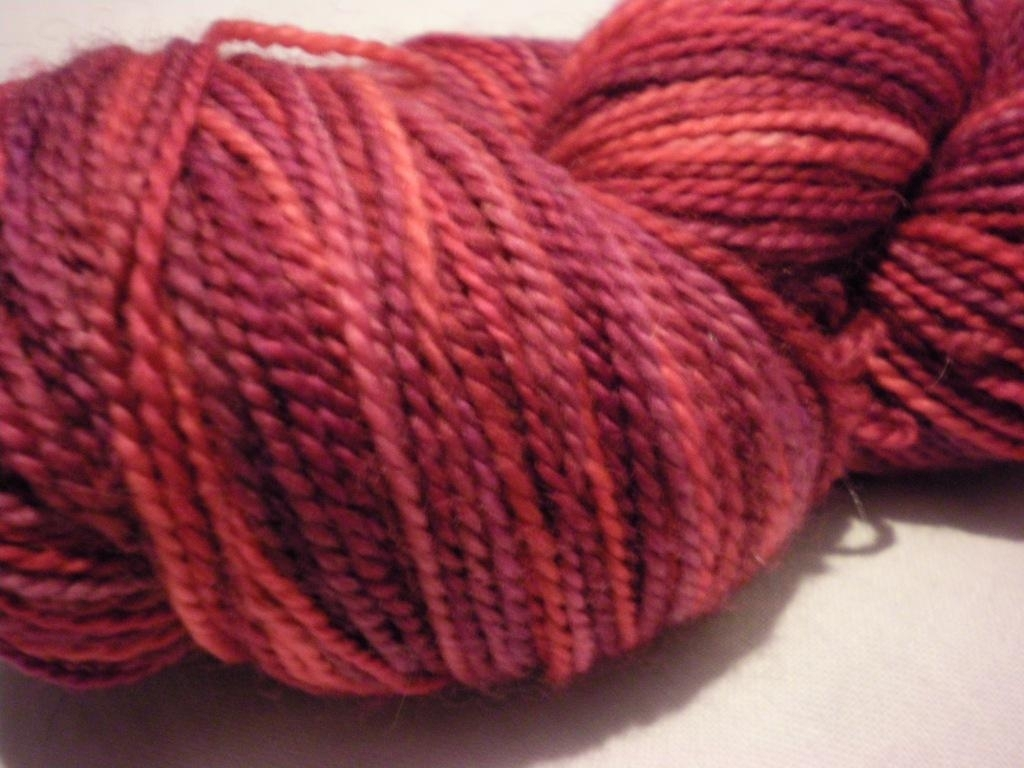What could this yarn be used for? This yarn could be used for a variety of crafting projects. Given its thickness and color, it would be well-suited for warm garments like sweaters, hats, or scarves, as well as for decorative items such as blankets and throws that require a cozy and inviting appearance. 